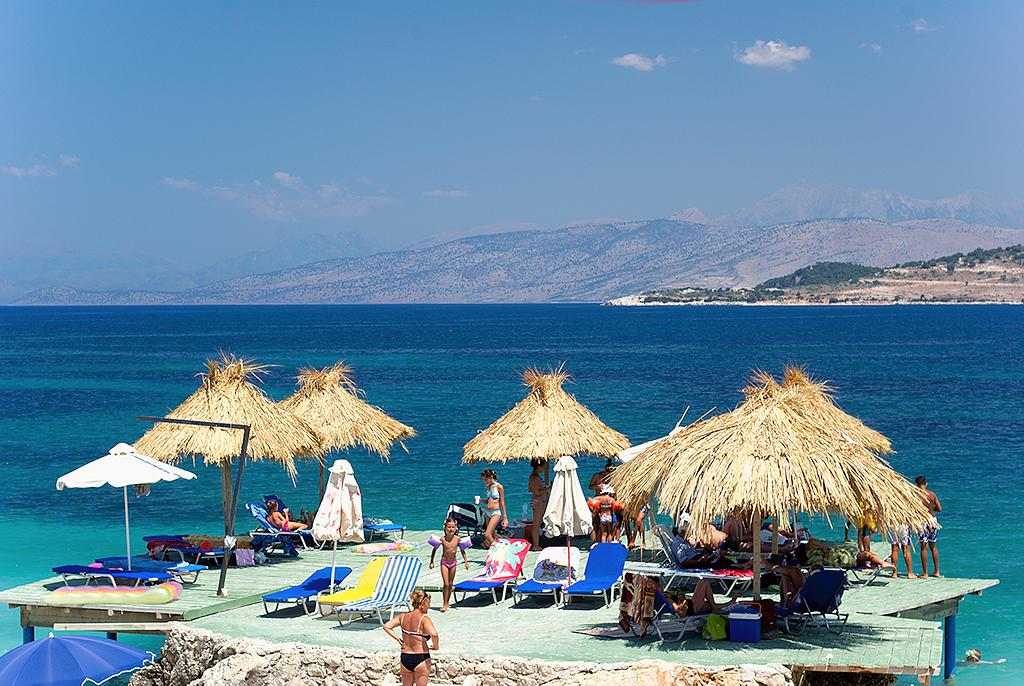What type of structures are present in the image? There are huts in the image. What type of furniture is present in the image? There is a chair in the image. What type of objects are present in the image that people might use for sleeping? There are beds in the image. How many persons can be seen in the image? There are persons in the image. What can be seen in the background of the image? There is water, mountains, and clouds in the sky in the background of the image. What type of cord is being used to connect the cup to the ground in the image? There is no cup or cord present in the image. How does the ground affect the stability of the huts in the image? The ground does not affect the stability of the huts in the image, as there is no mention of any instability or ground-related issues. 